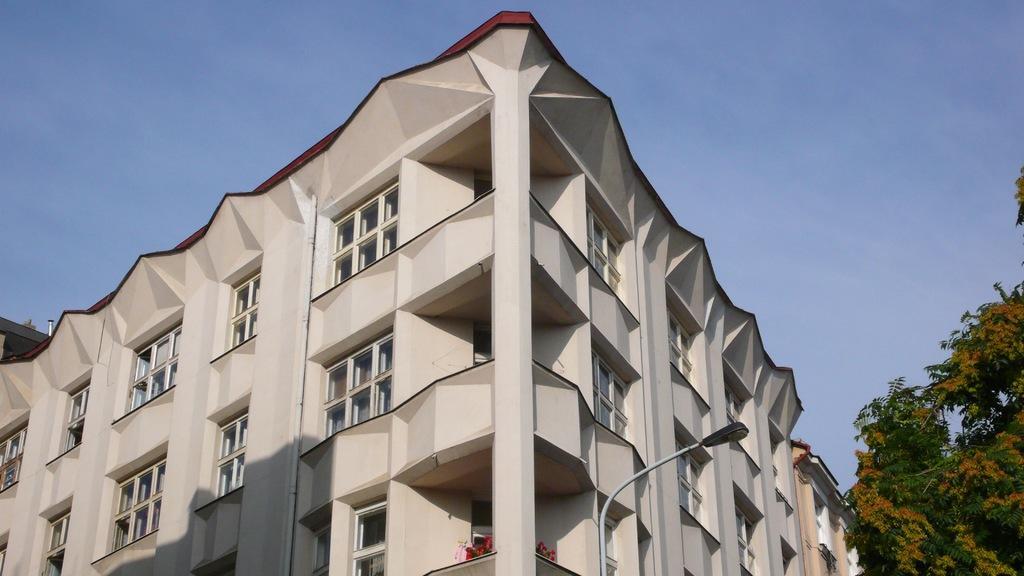Describe this image in one or two sentences. In this image we can see a building and it is having many windows. There is a street light in the image. We can see the sky in the image. There are many flowers to a plant at the bottom of the image. There is a tree at the right side of the image. 